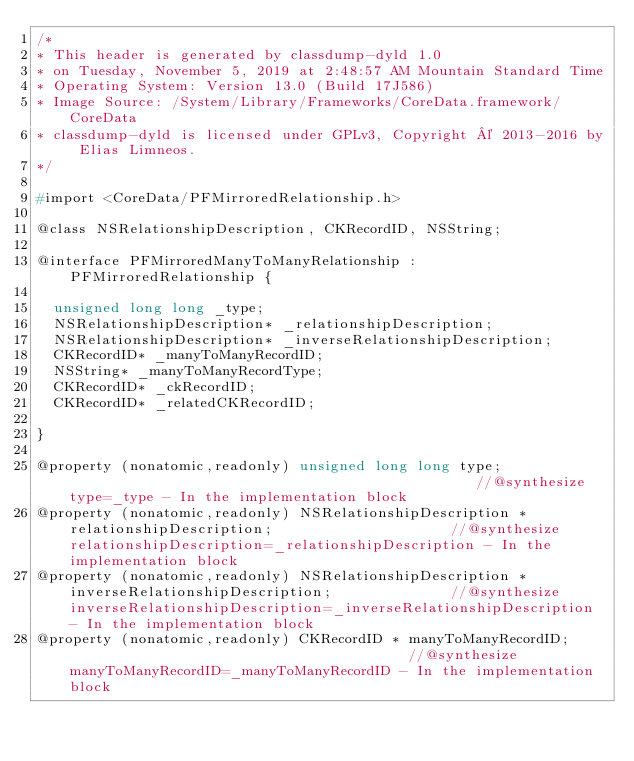<code> <loc_0><loc_0><loc_500><loc_500><_C_>/*
* This header is generated by classdump-dyld 1.0
* on Tuesday, November 5, 2019 at 2:48:57 AM Mountain Standard Time
* Operating System: Version 13.0 (Build 17J586)
* Image Source: /System/Library/Frameworks/CoreData.framework/CoreData
* classdump-dyld is licensed under GPLv3, Copyright © 2013-2016 by Elias Limneos.
*/

#import <CoreData/PFMirroredRelationship.h>

@class NSRelationshipDescription, CKRecordID, NSString;

@interface PFMirroredManyToManyRelationship : PFMirroredRelationship {

	unsigned long long _type;
	NSRelationshipDescription* _relationshipDescription;
	NSRelationshipDescription* _inverseRelationshipDescription;
	CKRecordID* _manyToManyRecordID;
	NSString* _manyToManyRecordType;
	CKRecordID* _ckRecordID;
	CKRecordID* _relatedCKRecordID;

}

@property (nonatomic,readonly) unsigned long long type;                                                 //@synthesize type=_type - In the implementation block
@property (nonatomic,readonly) NSRelationshipDescription * relationshipDescription;                     //@synthesize relationshipDescription=_relationshipDescription - In the implementation block
@property (nonatomic,readonly) NSRelationshipDescription * inverseRelationshipDescription;              //@synthesize inverseRelationshipDescription=_inverseRelationshipDescription - In the implementation block
@property (nonatomic,readonly) CKRecordID * manyToManyRecordID;                                         //@synthesize manyToManyRecordID=_manyToManyRecordID - In the implementation block</code> 